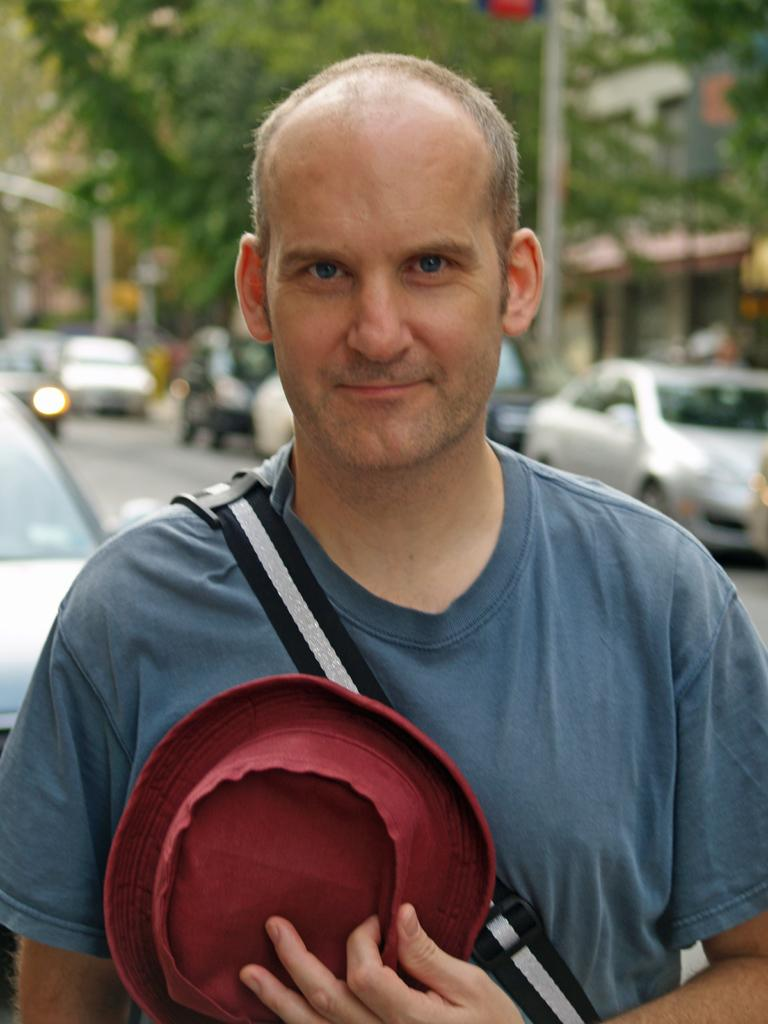Who is present in the image? There is a man in the image. What is the man holding in the image? The man is holding a cap. What can be seen in the background of the image? There are vehicles, poles, and trees visible in the background of the image. What arithmetic problem is the man solving in the image? There is no indication in the image that the man is solving an arithmetic problem. 